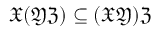Convert formula to latex. <formula><loc_0><loc_0><loc_500><loc_500>{ \mathfrak { X } } ( { \mathfrak { Y } } { \mathfrak { Z } } ) \subseteq ( { \mathfrak { X } } { \mathfrak { Y } } ) { \mathfrak { Z } }</formula> 